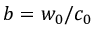Convert formula to latex. <formula><loc_0><loc_0><loc_500><loc_500>b = w _ { 0 } / c _ { 0 }</formula> 